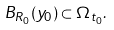<formula> <loc_0><loc_0><loc_500><loc_500>B _ { R _ { 0 } } ( y _ { 0 } ) \subset \Omega _ { t _ { 0 } } .</formula> 